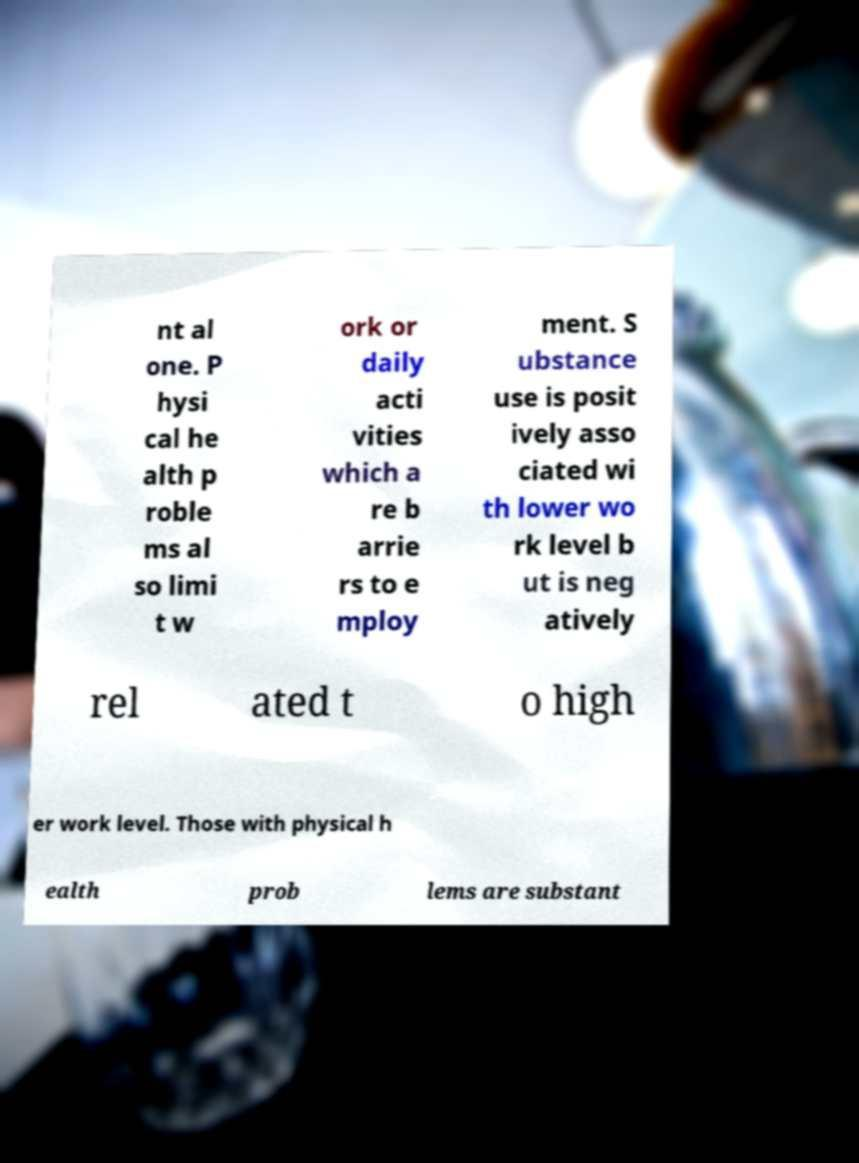Please identify and transcribe the text found in this image. nt al one. P hysi cal he alth p roble ms al so limi t w ork or daily acti vities which a re b arrie rs to e mploy ment. S ubstance use is posit ively asso ciated wi th lower wo rk level b ut is neg atively rel ated t o high er work level. Those with physical h ealth prob lems are substant 